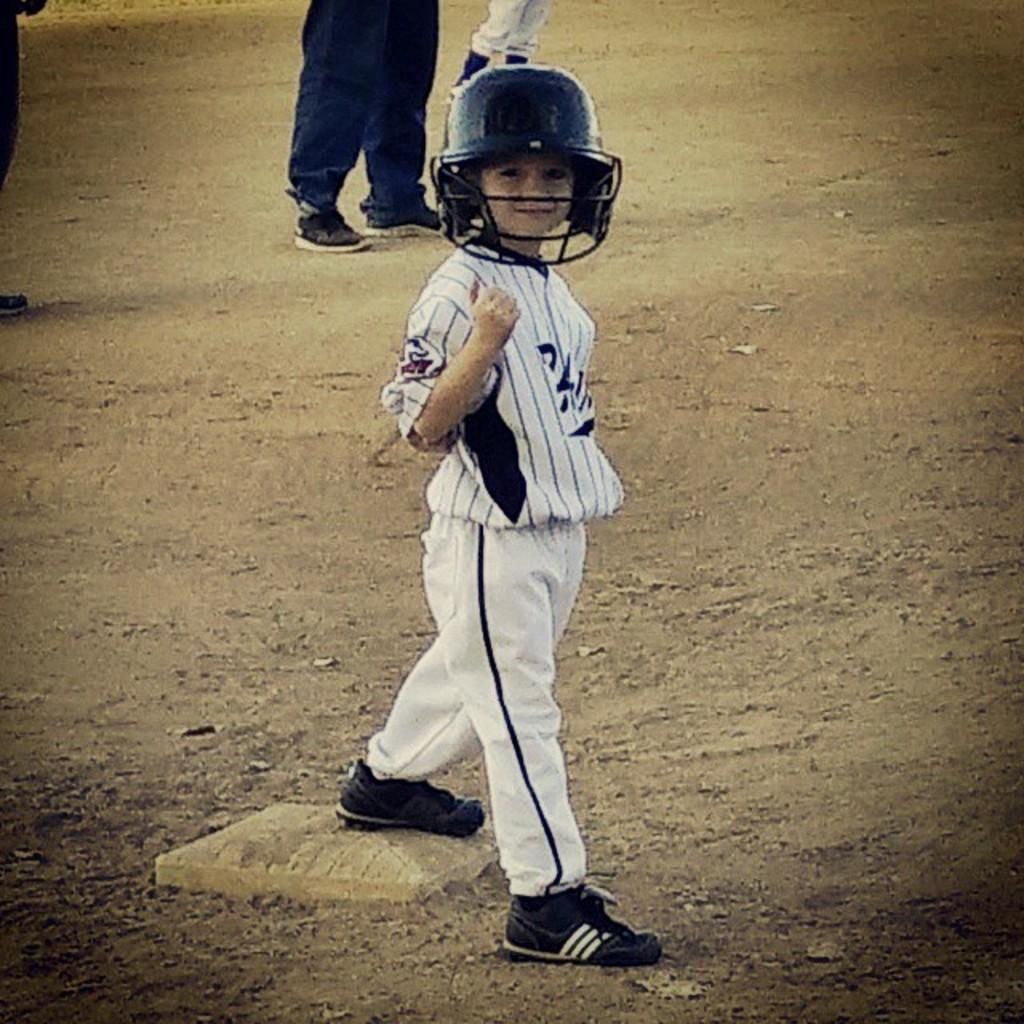Who is the main subject in the image? There is a boy in the image. What is the boy doing in the image? The boy is standing on the ground. What is the boy wearing on his head? The boy is wearing a helmet. What color are the boy's clothes? The boy is wearing white clothes. What is the boy wearing on his feet? The boy is wearing shoes. What can be seen in the background of the image? There are people in the background of the image. What are the people in the background doing? The people in the background are standing on the ground. What type of food is the boy eating in the image? There is no food visible in the image, and the boy is not shown eating anything. What type of lipstick is the boy wearing in the image? The boy is not wearing lipstick in the image, as he is a boy and lipstick is typically worn by females. 